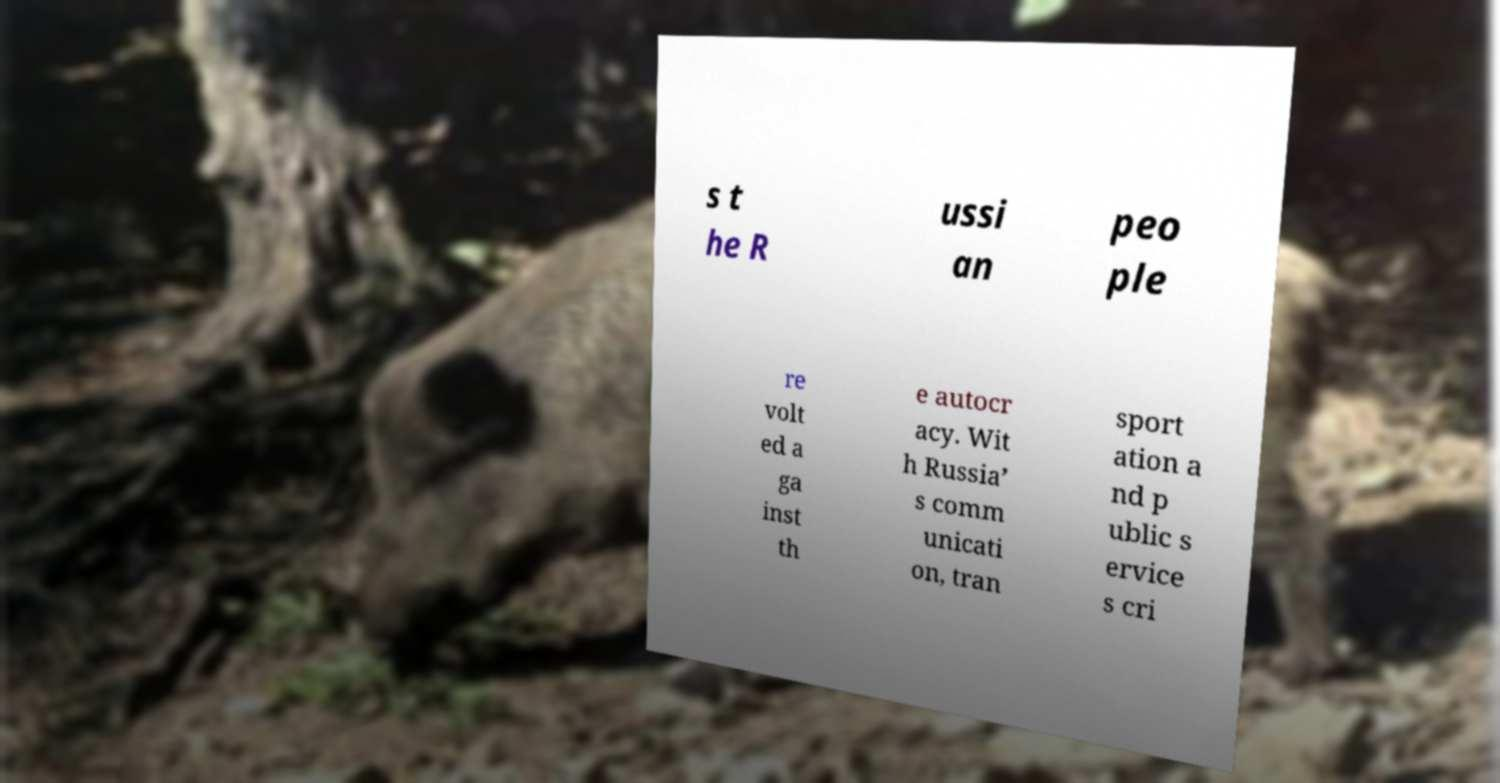Please read and relay the text visible in this image. What does it say? s t he R ussi an peo ple re volt ed a ga inst th e autocr acy. Wit h Russia’ s comm unicati on, tran sport ation a nd p ublic s ervice s cri 